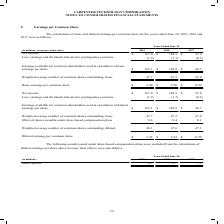According to Carpenter Technology's financial document, What was the Diluted earnings per common share in 2019? According to the financial document, $3.43. The relevant text states: "Diluted earnings per common share $ 3.43 $ 3.92 $ 0.99..." Also, What was the Basic earnings per common share in 2018? According to the financial document, $3.96. The relevant text states: "Basic earnings per common share $ 3.46 $ 3.96 $ 0.99..." Also, In which years is the diluted earnings per common share calculated? The document contains multiple relevant values: 2019, 2018, 2017. From the document: "(in millions, except per share data) 2019 2018 2017 Net income $ 167.0 $ 188.5 $ 47.0 Less: earnings and dividends allocated to participating securiti..." Additionally, In which year was the Weighted average number of common shares outstanding, basic largest? According to the financial document, 2019. The relevant text states: "(in millions, except per share data) 2019 2018 2017 Net income $ 167.0 $ 188.5 $ 47.0 Less: earnings and dividends allocated to participating..." Also, can you calculate: What was the change in Weighted average number of common shares outstanding, basic in 2019 from 2018? Based on the calculation: 47.7-47.2, the result is 0.5 (in millions). This is based on the information: "verage number of common shares outstanding, basic 47.7 47.2 47.0 e number of common shares outstanding, basic 47.7 47.2 47.0..." The key data points involved are: 47.2, 47.7. Also, can you calculate: What was the percentage change in Weighted average number of common shares outstanding, basic in 2019 from 2018? To answer this question, I need to perform calculations using the financial data. The calculation is: (47.7-47.2)/47.2, which equals 1.06 (percentage). This is based on the information: "verage number of common shares outstanding, basic 47.7 47.2 47.0 e number of common shares outstanding, basic 47.7 47.2 47.0..." The key data points involved are: 47.2, 47.7. 